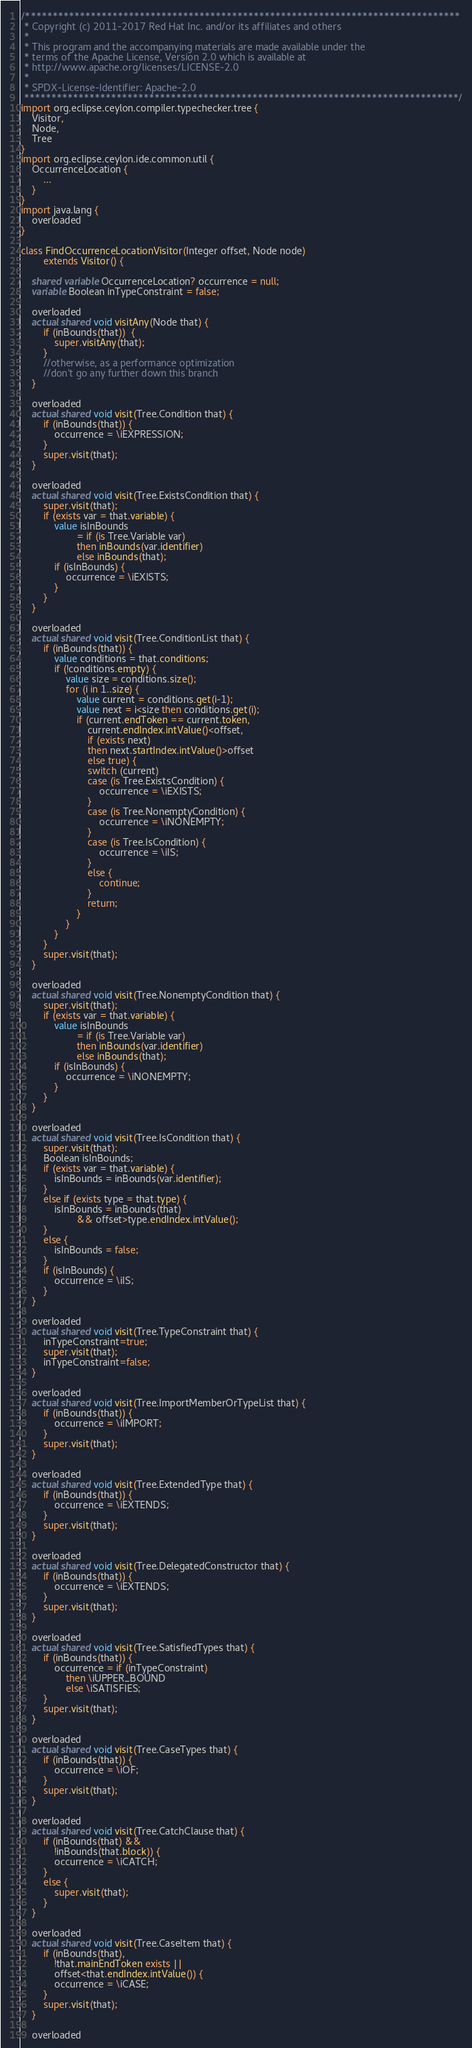<code> <loc_0><loc_0><loc_500><loc_500><_Ceylon_>/********************************************************************************
 * Copyright (c) 2011-2017 Red Hat Inc. and/or its affiliates and others
 *
 * This program and the accompanying materials are made available under the 
 * terms of the Apache License, Version 2.0 which is available at
 * http://www.apache.org/licenses/LICENSE-2.0
 *
 * SPDX-License-Identifier: Apache-2.0 
 ********************************************************************************/
import org.eclipse.ceylon.compiler.typechecker.tree {
    Visitor,
    Node,
    Tree
}
import org.eclipse.ceylon.ide.common.util {
    OccurrenceLocation {
        ...
    }
}
import java.lang {
    overloaded
}

class FindOccurrenceLocationVisitor(Integer offset, Node node) 
        extends Visitor() {
    
    shared variable OccurrenceLocation? occurrence = null;
    variable Boolean inTypeConstraint = false;

    overloaded
    actual shared void visitAny(Node that) {
        if (inBounds(that))  {
            super.visitAny(that);
        }
        //otherwise, as a performance optimization
        //don't go any further down this branch
    }

    overloaded
    actual shared void visit(Tree.Condition that) {
        if (inBounds(that)) {
            occurrence = \iEXPRESSION;
        }
        super.visit(that);
    }

    overloaded
    actual shared void visit(Tree.ExistsCondition that) {
        super.visit(that);
        if (exists var = that.variable) {
            value isInBounds 
                    = if (is Tree.Variable var) 
                    then inBounds(var.identifier) 
                    else inBounds(that);
            if (isInBounds) {
                occurrence = \iEXISTS;
            }
        }
    }

    overloaded
    actual shared void visit(Tree.ConditionList that) {
        if (inBounds(that)) {
            value conditions = that.conditions;
            if (!conditions.empty) {
                value size = conditions.size();
                for (i in 1..size) {
                    value current = conditions.get(i-1);
                    value next = i<size then conditions.get(i);
                    if (current.endToken == current.token,
                        current.endIndex.intValue()<offset,
                        if (exists next) 
                        then next.startIndex.intValue()>offset 
                        else true) {
                        switch (current)
                        case (is Tree.ExistsCondition) {
                            occurrence = \iEXISTS;
                        }
                        case (is Tree.NonemptyCondition) {
                            occurrence = \iNONEMPTY;
                        }
                        case (is Tree.IsCondition) {
                            occurrence = \iIS;
                        }
                        else {
                            continue;
                        }
                        return;
                    }
                }
            }
        }
        super.visit(that);
    }

    overloaded
    actual shared void visit(Tree.NonemptyCondition that) {
        super.visit(that);
        if (exists var = that.variable) {
            value isInBounds 
                    = if (is Tree.Variable var) 
                    then inBounds(var.identifier) 
                    else inBounds(that);
            if (isInBounds) {
                occurrence = \iNONEMPTY;
            }
        }
    }

    overloaded
    actual shared void visit(Tree.IsCondition that) {
        super.visit(that);
        Boolean isInBounds;
        if (exists var = that.variable) {
            isInBounds = inBounds(var.identifier);
        }
        else if (exists type = that.type) {
            isInBounds = inBounds(that) 
                    && offset>type.endIndex.intValue();
        }
        else {
            isInBounds = false;
        }
        if (isInBounds) {
            occurrence = \iIS;
        }
    }

    overloaded
    actual shared void visit(Tree.TypeConstraint that) {
        inTypeConstraint=true;
        super.visit(that);
        inTypeConstraint=false;
    }

    overloaded
    actual shared void visit(Tree.ImportMemberOrTypeList that) {
        if (inBounds(that)) {
            occurrence = \iIMPORT;
        }
        super.visit(that);
    }

    overloaded
    actual shared void visit(Tree.ExtendedType that) {
        if (inBounds(that)) {
            occurrence = \iEXTENDS;
        }
        super.visit(that);
    }

    overloaded
    actual shared void visit(Tree.DelegatedConstructor that) {
        if (inBounds(that)) {
            occurrence = \iEXTENDS;
        }
        super.visit(that);
    }

    overloaded
    actual shared void visit(Tree.SatisfiedTypes that) {
        if (inBounds(that)) {
            occurrence = if (inTypeConstraint) 
                then \iUPPER_BOUND 
                else \iSATISFIES;
        }
        super.visit(that);
    }

    overloaded
    actual shared void visit(Tree.CaseTypes that) {
        if (inBounds(that)) {
            occurrence = \iOF;
        }
        super.visit(that);
    }

    overloaded
    actual shared void visit(Tree.CatchClause that) {
        if (inBounds(that) && 
            !inBounds(that.block)) {
            occurrence = \iCATCH;
        }
        else {
            super.visit(that);
        }
    }

    overloaded
    actual shared void visit(Tree.CaseItem that) {
        if (inBounds(that),
            !that.mainEndToken exists ||
            offset<that.endIndex.intValue()) {
            occurrence = \iCASE;
        }
        super.visit(that);
    }

    overloaded</code> 